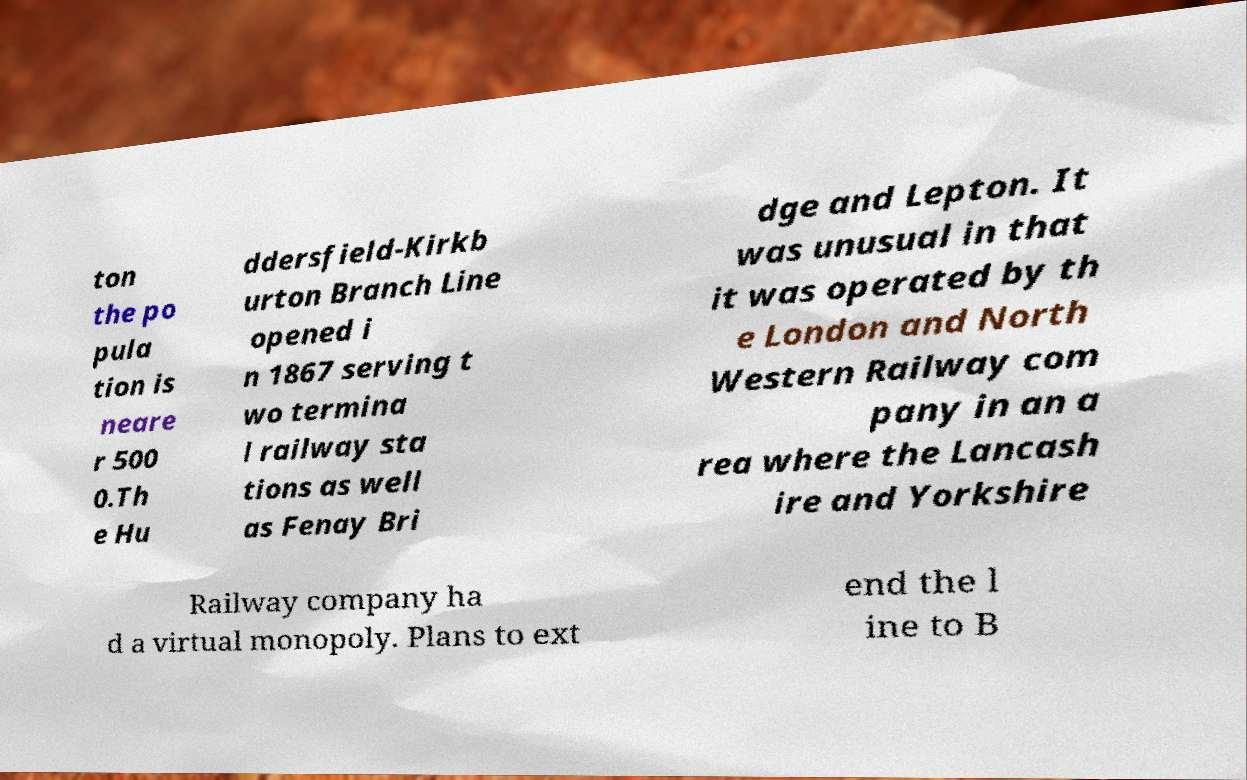Could you extract and type out the text from this image? ton the po pula tion is neare r 500 0.Th e Hu ddersfield-Kirkb urton Branch Line opened i n 1867 serving t wo termina l railway sta tions as well as Fenay Bri dge and Lepton. It was unusual in that it was operated by th e London and North Western Railway com pany in an a rea where the Lancash ire and Yorkshire Railway company ha d a virtual monopoly. Plans to ext end the l ine to B 